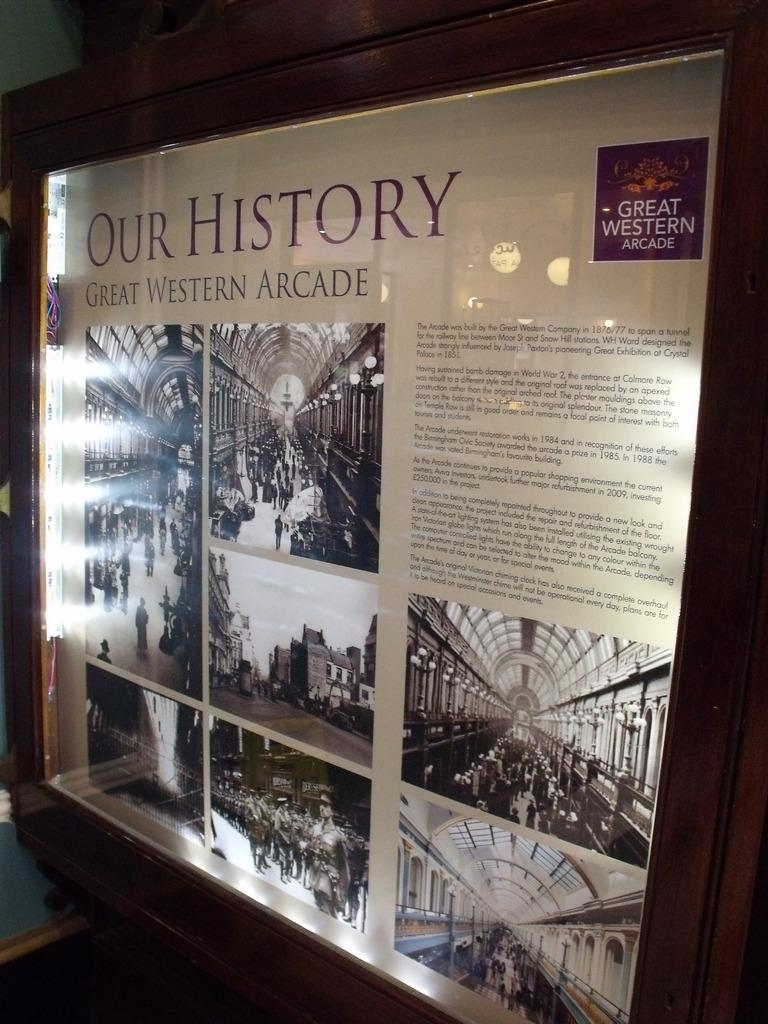<image>
Write a terse but informative summary of the picture. A poster of the Great Western Arcade which was built by the Great Western Company. 